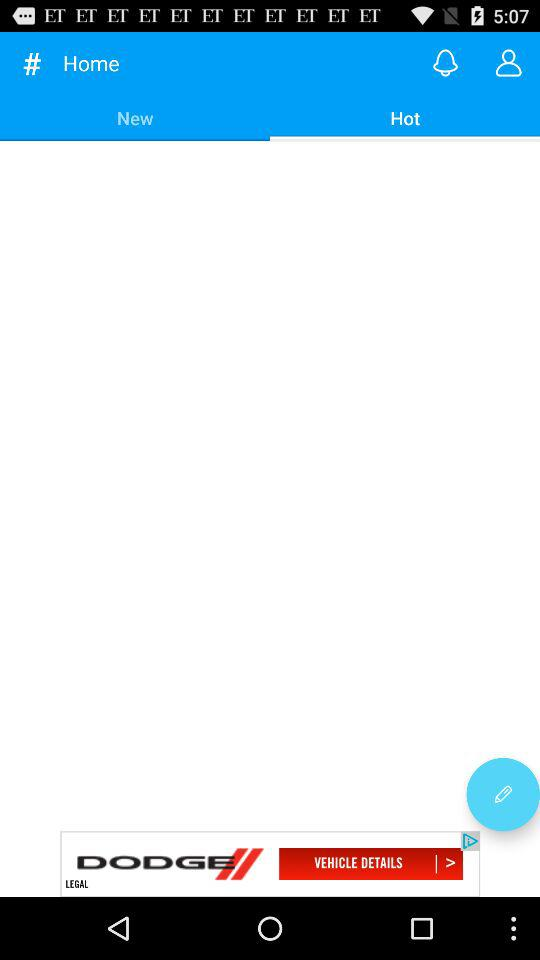Which tab is selected? The selected tab is Hot. 